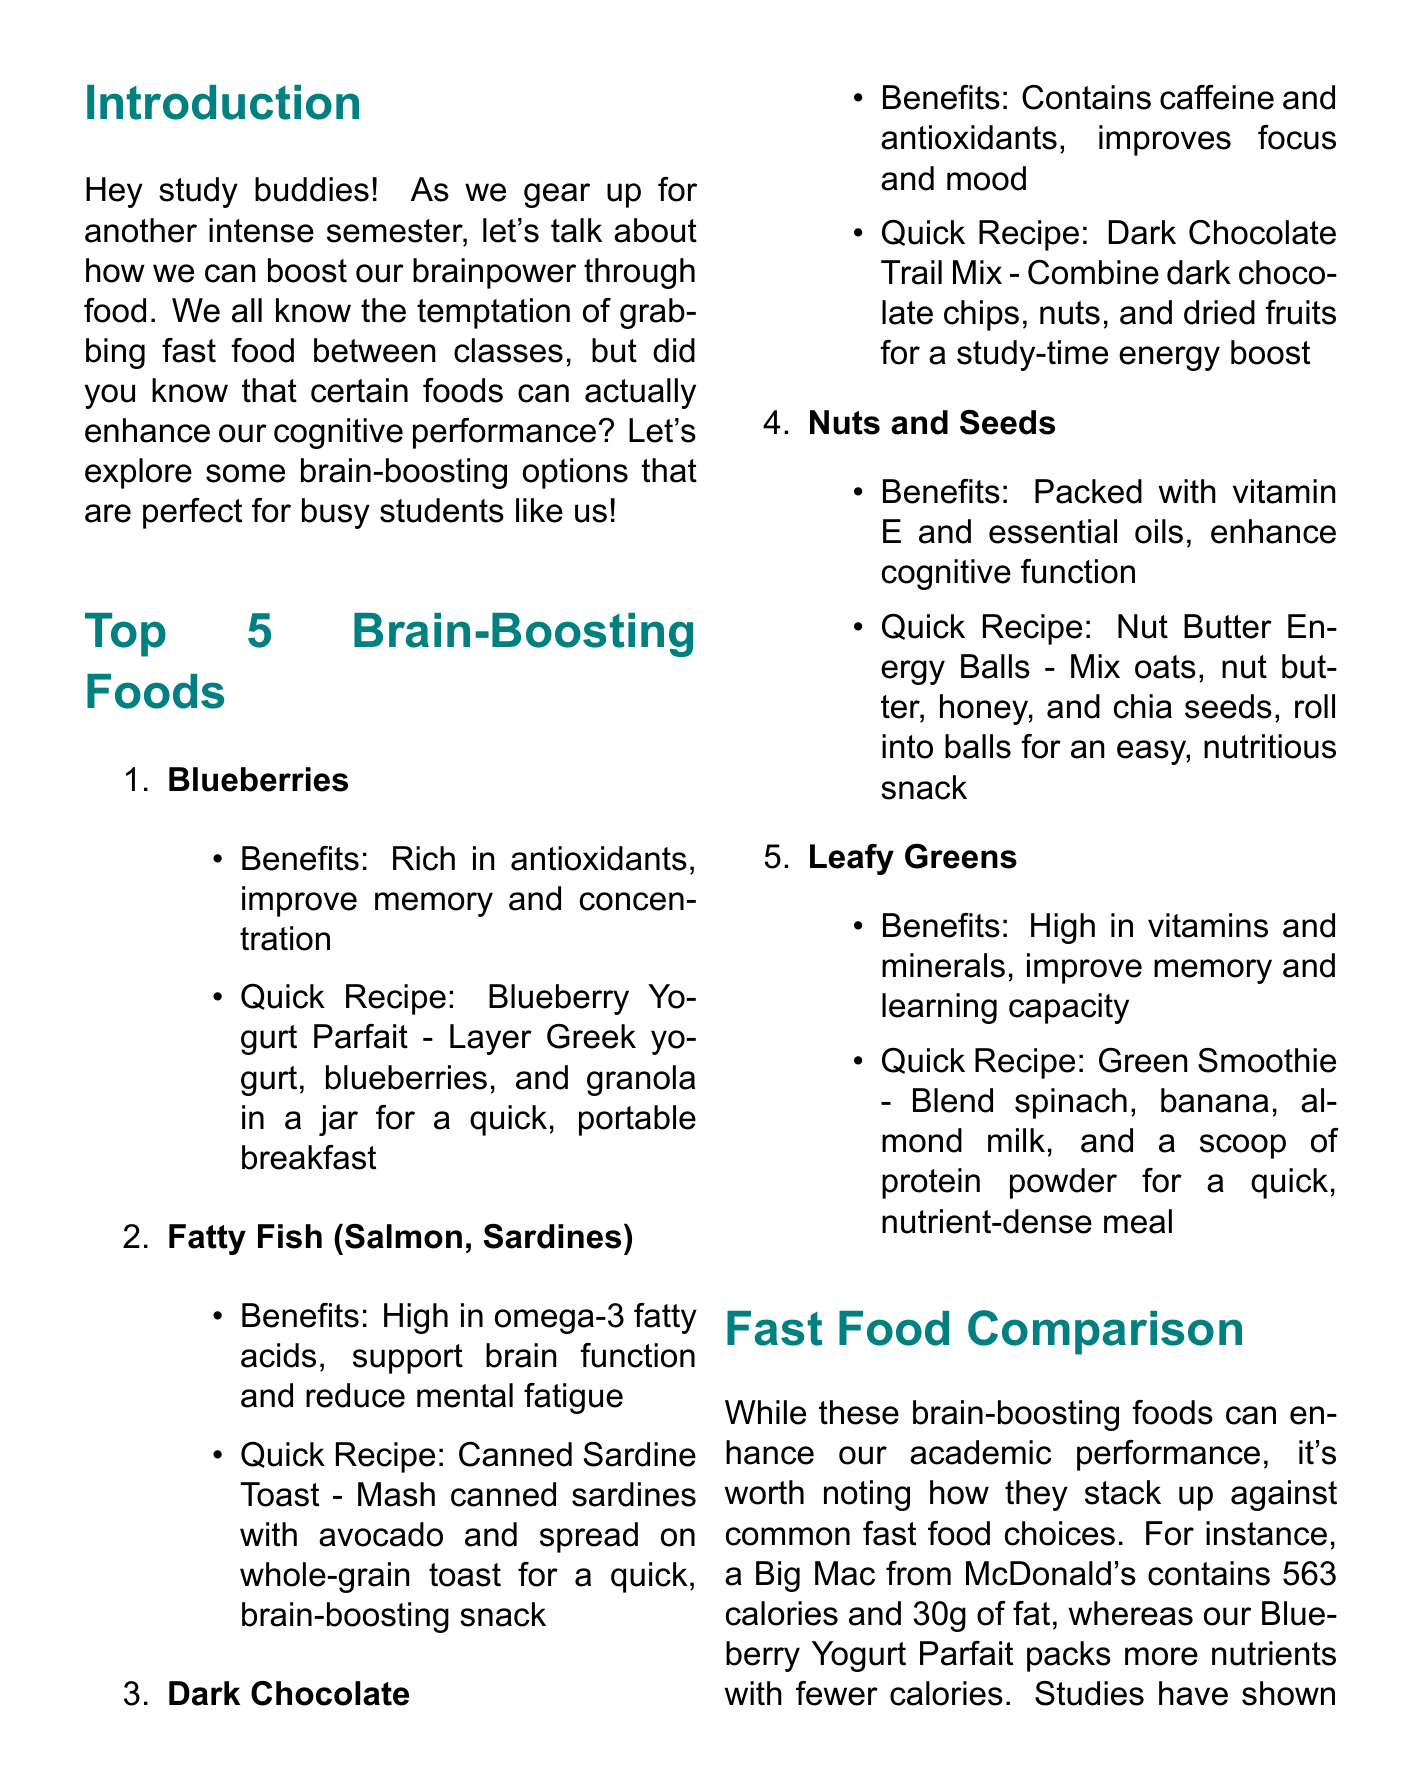What are the top brain-boosting foods? The document lists five brain-boosting foods: Blueberries, Fatty Fish (Salmon, Sardines), Dark Chocolate, Nuts and Seeds, Leafy Greens.
Answer: Blueberries, Fatty Fish, Dark Chocolate, Nuts and Seeds, Leafy Greens What is the quick recipe for Blueberries? The document provides a quick recipe for Blueberries: Layer Greek yogurt, blueberries, and granola in a jar for a quick, portable breakfast.
Answer: Blueberry Yogurt Parfait How many calories does a Big Mac contain? The document states that a Big Mac from McDonald's contains 563 calories.
Answer: 563 What benefits do Nuts and Seeds provide? The document mentions that Nuts and Seeds are packed with vitamin E and essential oils, enhancing cognitive function.
Answer: Enhance cognitive function What study tip is suggested for using brain foods? The document suggests incorporating brain foods into the next study session by making a big batch of Dark Chocolate Trail Mix to share while reviewing notes.
Answer: Dark Chocolate Trail Mix Which brain food is high in omega-3 fatty acids? The document notes that Fatty Fish, such as Salmon and Sardines, are high in omega-3 fatty acids.
Answer: Fatty Fish How are the nutrients of the Blueberry Yogurt Parfait compared to a Big Mac? The document states that the Blueberry Yogurt Parfait packs more nutrients with fewer calories than a Big Mac.
Answer: More nutrients, fewer calories What does the conclusion encourage readers to do? The conclusion encourages readers to swap out one fast food meal per week with one of the brain-boosting options.
Answer: Swap out one fast food meal per week How can students contribute to the brain food collection? The document invites readers to share their favorite brain-boosting recipes in the next study group meeting.
Answer: Share favorite recipes 